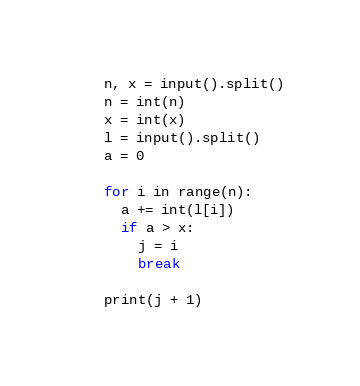Convert code to text. <code><loc_0><loc_0><loc_500><loc_500><_Python_>n, x = input().split()
n = int(n)
x = int(x)
l = input().split()
a = 0

for i in range(n):
  a += int(l[i])
  if a > x:
    j = i
    break
    
print(j + 1)</code> 